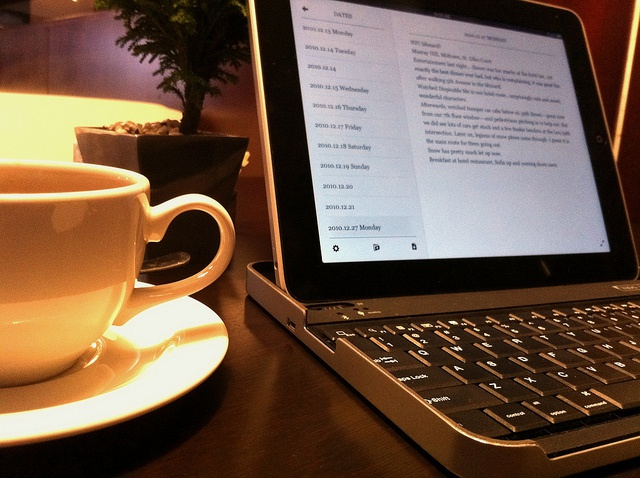Describe the objects in this image and their specific colors. I can see laptop in black, darkgray, maroon, and lightgray tones, cup in black, brown, orange, and red tones, and potted plant in black, maroon, and brown tones in this image. 